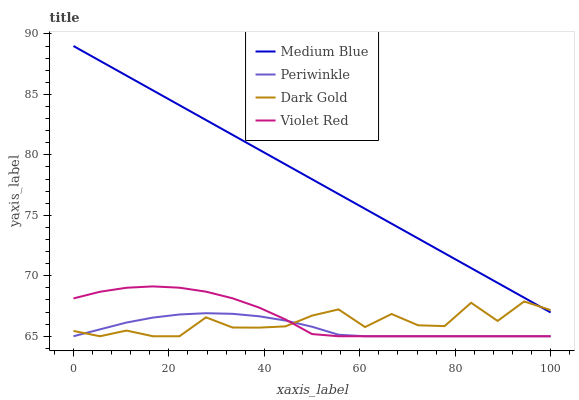Does Periwinkle have the minimum area under the curve?
Answer yes or no. Yes. Does Medium Blue have the maximum area under the curve?
Answer yes or no. Yes. Does Violet Red have the minimum area under the curve?
Answer yes or no. No. Does Violet Red have the maximum area under the curve?
Answer yes or no. No. Is Medium Blue the smoothest?
Answer yes or no. Yes. Is Dark Gold the roughest?
Answer yes or no. Yes. Is Violet Red the smoothest?
Answer yes or no. No. Is Violet Red the roughest?
Answer yes or no. No. Does Medium Blue have the lowest value?
Answer yes or no. No. Does Medium Blue have the highest value?
Answer yes or no. Yes. Does Violet Red have the highest value?
Answer yes or no. No. Is Violet Red less than Medium Blue?
Answer yes or no. Yes. Is Medium Blue greater than Periwinkle?
Answer yes or no. Yes. Does Periwinkle intersect Violet Red?
Answer yes or no. Yes. Is Periwinkle less than Violet Red?
Answer yes or no. No. Is Periwinkle greater than Violet Red?
Answer yes or no. No. Does Violet Red intersect Medium Blue?
Answer yes or no. No. 